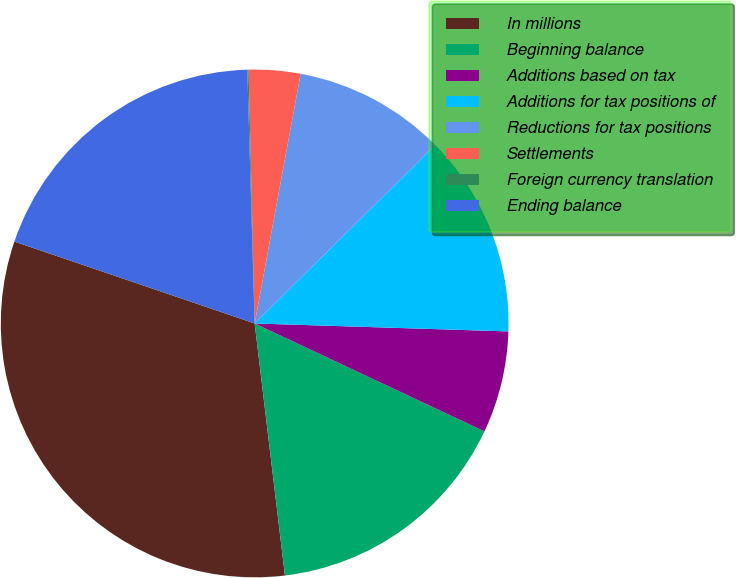Convert chart. <chart><loc_0><loc_0><loc_500><loc_500><pie_chart><fcel>In millions<fcel>Beginning balance<fcel>Additions based on tax<fcel>Additions for tax positions of<fcel>Reductions for tax positions<fcel>Settlements<fcel>Foreign currency translation<fcel>Ending balance<nl><fcel>32.13%<fcel>16.11%<fcel>6.49%<fcel>12.9%<fcel>9.7%<fcel>3.28%<fcel>0.08%<fcel>19.31%<nl></chart> 